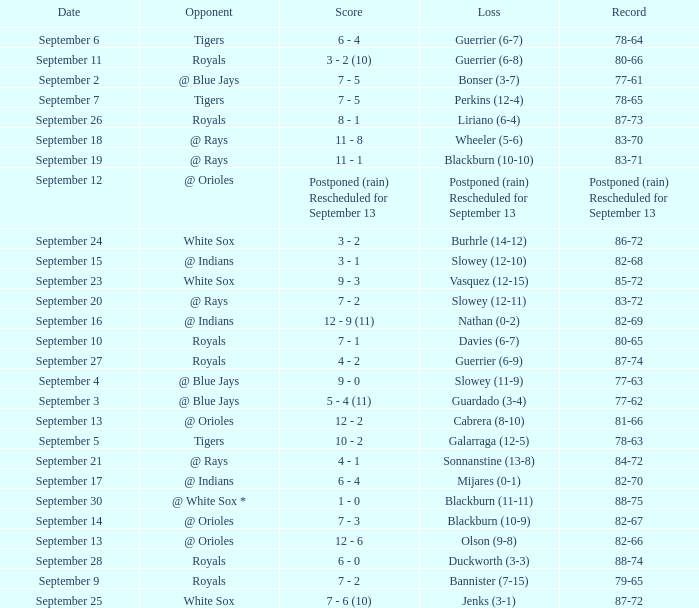What date has the record of 77-62? September 3. 